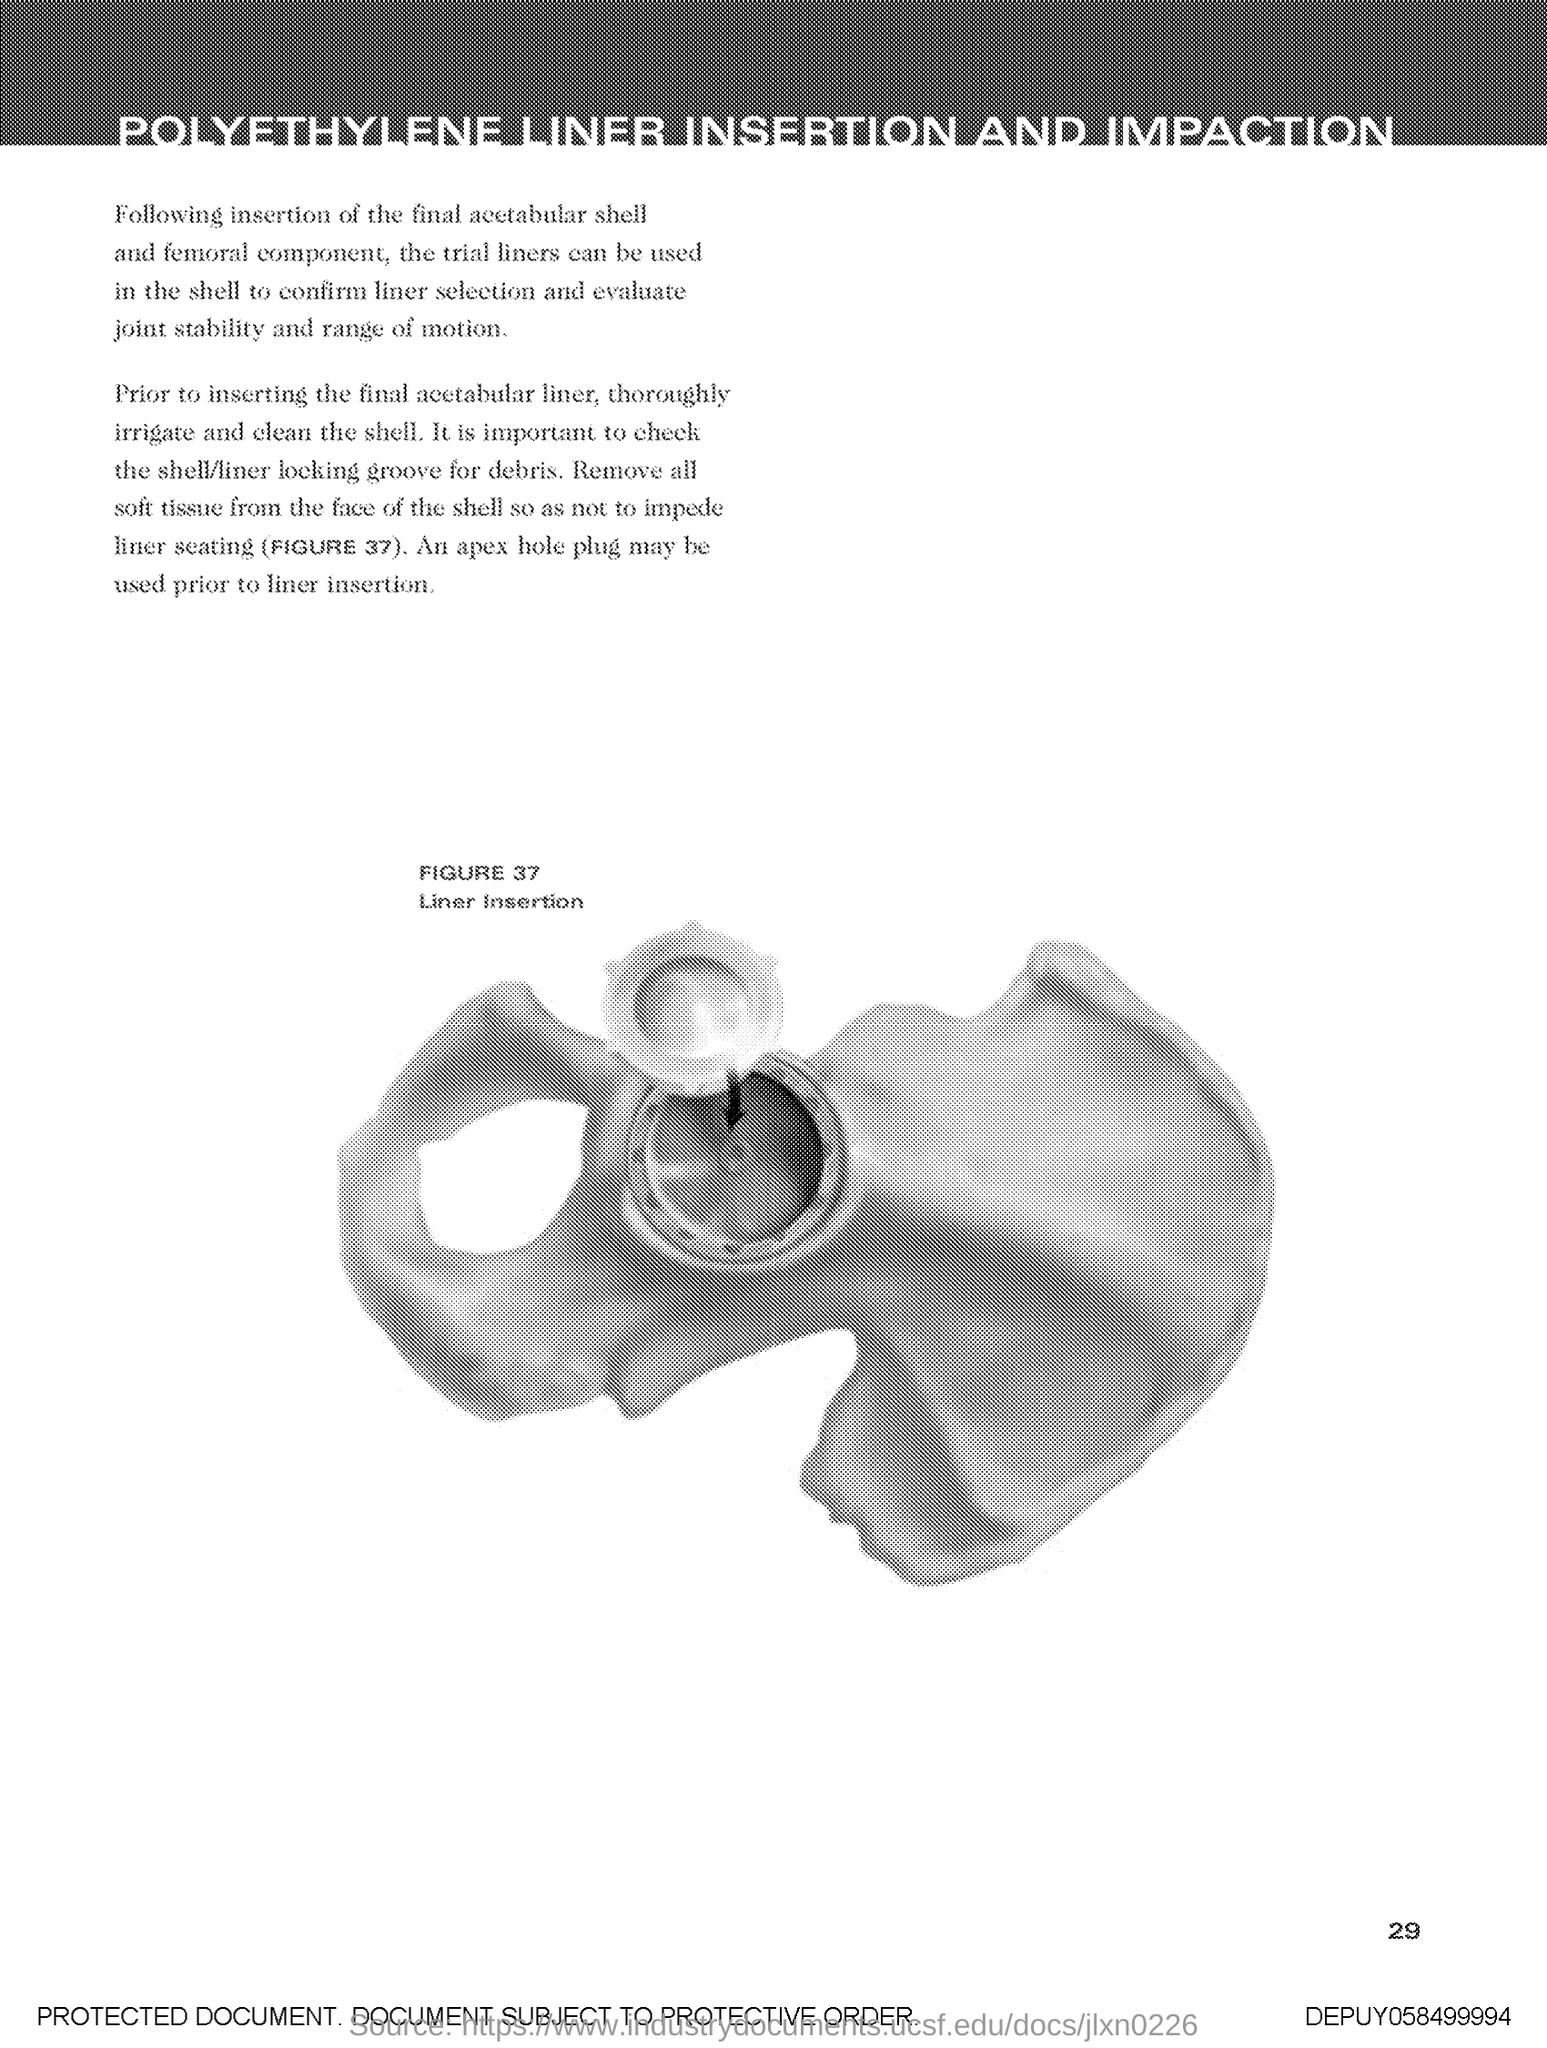What is the Figure number?
Your response must be concise. 37. What is the Figure Name?
Provide a succinct answer. Liner Insertion. 